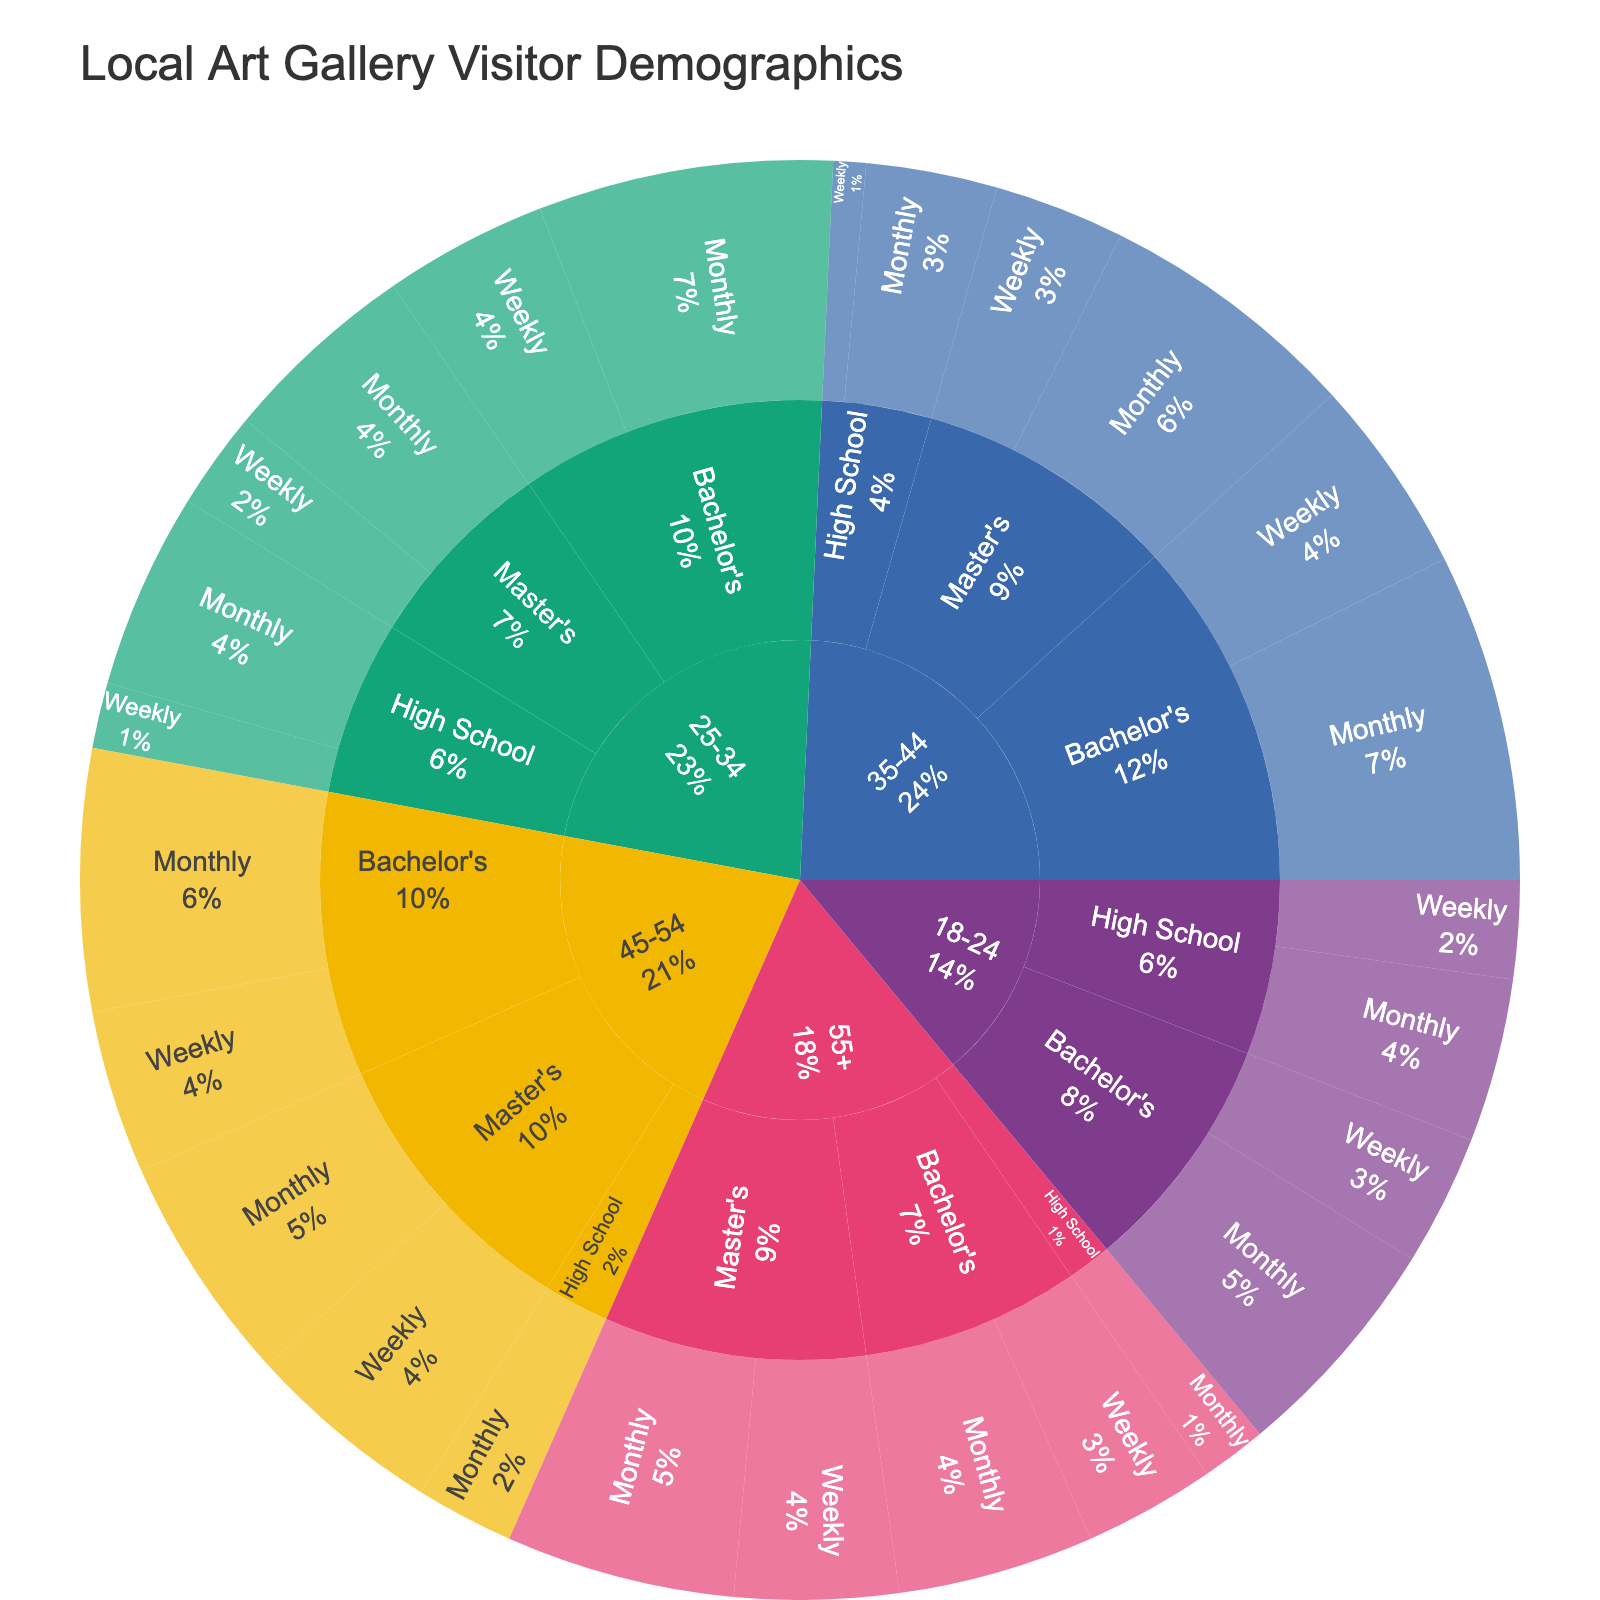What is the total number of visitors who visit the gallery weekly in the 25-34 age group? To find the total weekly visitors for the 25-34 age group, sum the values for 'High School', 'Bachelor's', and 'Master's' under 'Weekly'. The values are 10 (High School) + 25 (Bachelor's) + 15 (Master's) = 50.
Answer: 50 Which education level within the 45-54 age group has the highest percentage of monthly visitors? Look at the 45-54 age group and compare the 'Monthly' percentages for 'High School', 'Bachelor's', and 'Master's'. 'Bachelor's' has 40 visitors, 'Master's' has 35, and 'High School' has 15. ‘Bachelor’s’ has the highest percentage.
Answer: Bachelor's How does the frequency of visits differ between those aged 18-24 with a Bachelor's degree and those aged 55+ with a Bachelor's degree? Compare the frequencies for the 18-24 and 55+ age groups with a Bachelor's degree. In the 18-24 group: Weekly (20) and Monthly (35). In the 55+ group: Weekly (20) and Monthly (30). Both age groups have the same weekly visitors (20), but the 18-24 group has more monthly visitors (35 vs. 30).
Answer: Weekly: Same, Monthly: 18-24 higher What is the total number of visitors from the ages 35-44 who have at least a Bachelor's degree? Total the visitors for Bachelor's (Weekly 30 + Monthly 50) and Master's (Weekly 20 + Monthly 40). Sum these: (30 + 50) + (20 + 40) = 140.
Answer: 140 Which age group has the highest weekly visitors overall? Sum the weekly values for each age group and identify the highest. 18-24: 15 + 20 = 35; 25-34: 10 + 25 + 15 = 50; 35-44: 5 + 30 + 20 = 55; 45-54: 25 + 30 = 55; 55+: 20 + 25 = 45. The 45-54 and 35-44 age groups both have the highest (55).
Answer: 45-54 and 35-44 Comparing the 25-34 and 35-44 age groups, which has more total visitors with a Master's degree (both weekly and monthly)? Sum the Master's degree values for each age group for 'Weekly' and 'Monthly'. 25-34: Weekly (15) + Monthly (30) = 45. 35-44: Weekly (20) + Monthly (40) = 60. 35-44 has more.
Answer: 35-44 What's the total number of monthly visitors aged 18-24? Sum the monthly visitors for all education levels within the 18-24 age group: High School (25) + Bachelor's (35) = 60.
Answer: 60 Which age group with a Bachelor’s degree has the highest total number of visitors? Sum the Bachelor's visits (Weekly + Monthly) for each age group. 18-24: 20+35=55; 25-34: 25+45=70; 35-44: 30+50=80; 45-54: 25+40=65; 55+: 20+30=50. The 35-44 group has the highest total (80).
Answer: 35-44 